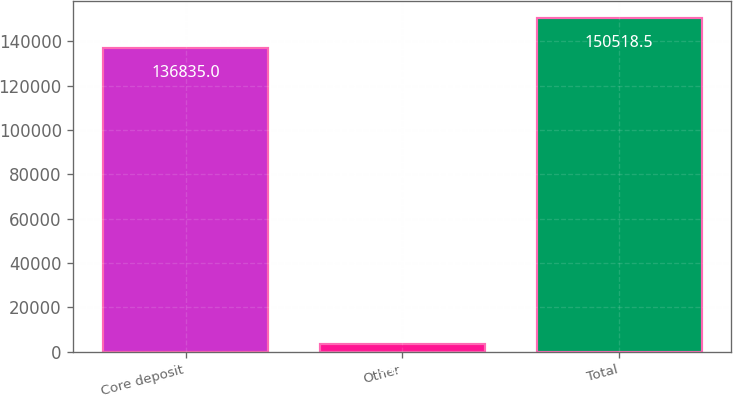<chart> <loc_0><loc_0><loc_500><loc_500><bar_chart><fcel>Core deposit<fcel>Other<fcel>Total<nl><fcel>136835<fcel>3433<fcel>150518<nl></chart> 